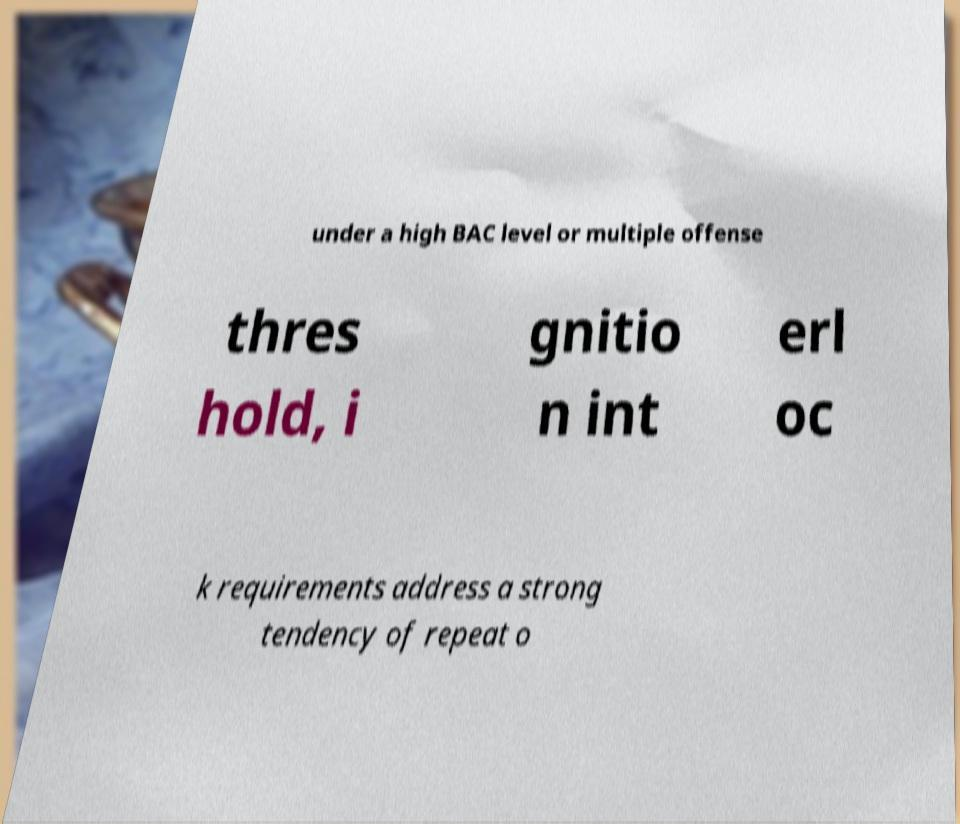There's text embedded in this image that I need extracted. Can you transcribe it verbatim? under a high BAC level or multiple offense thres hold, i gnitio n int erl oc k requirements address a strong tendency of repeat o 